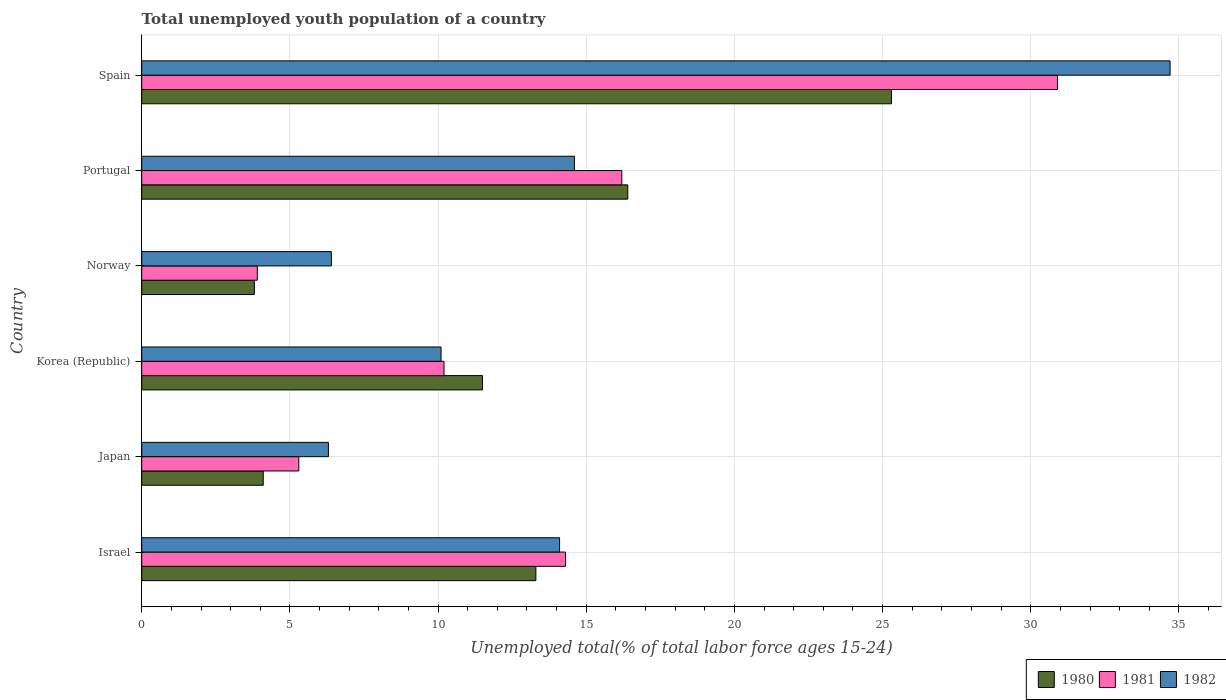How many groups of bars are there?
Your answer should be very brief. 6. Are the number of bars on each tick of the Y-axis equal?
Offer a terse response. Yes. How many bars are there on the 4th tick from the top?
Make the answer very short. 3. How many bars are there on the 4th tick from the bottom?
Provide a short and direct response. 3. What is the label of the 6th group of bars from the top?
Provide a succinct answer. Israel. What is the percentage of total unemployed youth population of a country in 1980 in Portugal?
Provide a succinct answer. 16.4. Across all countries, what is the maximum percentage of total unemployed youth population of a country in 1980?
Your answer should be very brief. 25.3. Across all countries, what is the minimum percentage of total unemployed youth population of a country in 1980?
Your answer should be very brief. 3.8. In which country was the percentage of total unemployed youth population of a country in 1981 maximum?
Provide a succinct answer. Spain. In which country was the percentage of total unemployed youth population of a country in 1982 minimum?
Give a very brief answer. Japan. What is the total percentage of total unemployed youth population of a country in 1980 in the graph?
Your answer should be very brief. 74.4. What is the difference between the percentage of total unemployed youth population of a country in 1982 in Israel and that in Japan?
Your answer should be compact. 7.8. What is the difference between the percentage of total unemployed youth population of a country in 1981 in Spain and the percentage of total unemployed youth population of a country in 1980 in Portugal?
Offer a very short reply. 14.5. What is the average percentage of total unemployed youth population of a country in 1980 per country?
Your response must be concise. 12.4. In how many countries, is the percentage of total unemployed youth population of a country in 1980 greater than 6 %?
Give a very brief answer. 4. What is the ratio of the percentage of total unemployed youth population of a country in 1982 in Korea (Republic) to that in Portugal?
Ensure brevity in your answer.  0.69. What is the difference between the highest and the second highest percentage of total unemployed youth population of a country in 1981?
Offer a very short reply. 14.7. What is the difference between the highest and the lowest percentage of total unemployed youth population of a country in 1981?
Ensure brevity in your answer.  27. In how many countries, is the percentage of total unemployed youth population of a country in 1981 greater than the average percentage of total unemployed youth population of a country in 1981 taken over all countries?
Offer a very short reply. 3. What does the 1st bar from the top in Portugal represents?
Make the answer very short. 1982. What does the 1st bar from the bottom in Japan represents?
Keep it short and to the point. 1980. Is it the case that in every country, the sum of the percentage of total unemployed youth population of a country in 1981 and percentage of total unemployed youth population of a country in 1980 is greater than the percentage of total unemployed youth population of a country in 1982?
Your answer should be very brief. Yes. How many countries are there in the graph?
Offer a terse response. 6. What is the difference between two consecutive major ticks on the X-axis?
Offer a terse response. 5. Does the graph contain any zero values?
Offer a terse response. No. Does the graph contain grids?
Your answer should be compact. Yes. Where does the legend appear in the graph?
Offer a terse response. Bottom right. What is the title of the graph?
Offer a terse response. Total unemployed youth population of a country. Does "1984" appear as one of the legend labels in the graph?
Give a very brief answer. No. What is the label or title of the X-axis?
Your response must be concise. Unemployed total(% of total labor force ages 15-24). What is the label or title of the Y-axis?
Your answer should be very brief. Country. What is the Unemployed total(% of total labor force ages 15-24) of 1980 in Israel?
Provide a short and direct response. 13.3. What is the Unemployed total(% of total labor force ages 15-24) in 1981 in Israel?
Provide a short and direct response. 14.3. What is the Unemployed total(% of total labor force ages 15-24) in 1982 in Israel?
Ensure brevity in your answer.  14.1. What is the Unemployed total(% of total labor force ages 15-24) in 1980 in Japan?
Give a very brief answer. 4.1. What is the Unemployed total(% of total labor force ages 15-24) of 1981 in Japan?
Provide a succinct answer. 5.3. What is the Unemployed total(% of total labor force ages 15-24) in 1982 in Japan?
Offer a very short reply. 6.3. What is the Unemployed total(% of total labor force ages 15-24) of 1980 in Korea (Republic)?
Offer a terse response. 11.5. What is the Unemployed total(% of total labor force ages 15-24) of 1981 in Korea (Republic)?
Your answer should be compact. 10.2. What is the Unemployed total(% of total labor force ages 15-24) in 1982 in Korea (Republic)?
Your answer should be compact. 10.1. What is the Unemployed total(% of total labor force ages 15-24) of 1980 in Norway?
Your answer should be very brief. 3.8. What is the Unemployed total(% of total labor force ages 15-24) in 1981 in Norway?
Offer a very short reply. 3.9. What is the Unemployed total(% of total labor force ages 15-24) in 1982 in Norway?
Your answer should be very brief. 6.4. What is the Unemployed total(% of total labor force ages 15-24) of 1980 in Portugal?
Ensure brevity in your answer.  16.4. What is the Unemployed total(% of total labor force ages 15-24) of 1981 in Portugal?
Your answer should be compact. 16.2. What is the Unemployed total(% of total labor force ages 15-24) in 1982 in Portugal?
Ensure brevity in your answer.  14.6. What is the Unemployed total(% of total labor force ages 15-24) of 1980 in Spain?
Give a very brief answer. 25.3. What is the Unemployed total(% of total labor force ages 15-24) in 1981 in Spain?
Offer a terse response. 30.9. What is the Unemployed total(% of total labor force ages 15-24) of 1982 in Spain?
Offer a very short reply. 34.7. Across all countries, what is the maximum Unemployed total(% of total labor force ages 15-24) in 1980?
Keep it short and to the point. 25.3. Across all countries, what is the maximum Unemployed total(% of total labor force ages 15-24) of 1981?
Provide a short and direct response. 30.9. Across all countries, what is the maximum Unemployed total(% of total labor force ages 15-24) of 1982?
Your answer should be compact. 34.7. Across all countries, what is the minimum Unemployed total(% of total labor force ages 15-24) of 1980?
Provide a succinct answer. 3.8. Across all countries, what is the minimum Unemployed total(% of total labor force ages 15-24) of 1981?
Give a very brief answer. 3.9. Across all countries, what is the minimum Unemployed total(% of total labor force ages 15-24) in 1982?
Ensure brevity in your answer.  6.3. What is the total Unemployed total(% of total labor force ages 15-24) of 1980 in the graph?
Your answer should be compact. 74.4. What is the total Unemployed total(% of total labor force ages 15-24) of 1981 in the graph?
Make the answer very short. 80.8. What is the total Unemployed total(% of total labor force ages 15-24) in 1982 in the graph?
Your answer should be very brief. 86.2. What is the difference between the Unemployed total(% of total labor force ages 15-24) of 1982 in Israel and that in Japan?
Ensure brevity in your answer.  7.8. What is the difference between the Unemployed total(% of total labor force ages 15-24) in 1980 in Israel and that in Korea (Republic)?
Your response must be concise. 1.8. What is the difference between the Unemployed total(% of total labor force ages 15-24) in 1982 in Israel and that in Korea (Republic)?
Offer a terse response. 4. What is the difference between the Unemployed total(% of total labor force ages 15-24) in 1982 in Israel and that in Norway?
Provide a short and direct response. 7.7. What is the difference between the Unemployed total(% of total labor force ages 15-24) of 1981 in Israel and that in Portugal?
Keep it short and to the point. -1.9. What is the difference between the Unemployed total(% of total labor force ages 15-24) of 1982 in Israel and that in Portugal?
Provide a succinct answer. -0.5. What is the difference between the Unemployed total(% of total labor force ages 15-24) in 1981 in Israel and that in Spain?
Provide a short and direct response. -16.6. What is the difference between the Unemployed total(% of total labor force ages 15-24) of 1982 in Israel and that in Spain?
Provide a short and direct response. -20.6. What is the difference between the Unemployed total(% of total labor force ages 15-24) of 1982 in Japan and that in Korea (Republic)?
Give a very brief answer. -3.8. What is the difference between the Unemployed total(% of total labor force ages 15-24) of 1981 in Japan and that in Portugal?
Ensure brevity in your answer.  -10.9. What is the difference between the Unemployed total(% of total labor force ages 15-24) in 1982 in Japan and that in Portugal?
Your answer should be compact. -8.3. What is the difference between the Unemployed total(% of total labor force ages 15-24) of 1980 in Japan and that in Spain?
Your answer should be very brief. -21.2. What is the difference between the Unemployed total(% of total labor force ages 15-24) of 1981 in Japan and that in Spain?
Make the answer very short. -25.6. What is the difference between the Unemployed total(% of total labor force ages 15-24) of 1982 in Japan and that in Spain?
Ensure brevity in your answer.  -28.4. What is the difference between the Unemployed total(% of total labor force ages 15-24) in 1980 in Korea (Republic) and that in Norway?
Your answer should be compact. 7.7. What is the difference between the Unemployed total(% of total labor force ages 15-24) in 1981 in Korea (Republic) and that in Norway?
Make the answer very short. 6.3. What is the difference between the Unemployed total(% of total labor force ages 15-24) in 1982 in Korea (Republic) and that in Norway?
Provide a short and direct response. 3.7. What is the difference between the Unemployed total(% of total labor force ages 15-24) in 1982 in Korea (Republic) and that in Portugal?
Offer a very short reply. -4.5. What is the difference between the Unemployed total(% of total labor force ages 15-24) of 1980 in Korea (Republic) and that in Spain?
Give a very brief answer. -13.8. What is the difference between the Unemployed total(% of total labor force ages 15-24) of 1981 in Korea (Republic) and that in Spain?
Make the answer very short. -20.7. What is the difference between the Unemployed total(% of total labor force ages 15-24) in 1982 in Korea (Republic) and that in Spain?
Your answer should be compact. -24.6. What is the difference between the Unemployed total(% of total labor force ages 15-24) of 1980 in Norway and that in Portugal?
Give a very brief answer. -12.6. What is the difference between the Unemployed total(% of total labor force ages 15-24) of 1981 in Norway and that in Portugal?
Ensure brevity in your answer.  -12.3. What is the difference between the Unemployed total(% of total labor force ages 15-24) of 1982 in Norway and that in Portugal?
Ensure brevity in your answer.  -8.2. What is the difference between the Unemployed total(% of total labor force ages 15-24) of 1980 in Norway and that in Spain?
Offer a terse response. -21.5. What is the difference between the Unemployed total(% of total labor force ages 15-24) of 1982 in Norway and that in Spain?
Provide a short and direct response. -28.3. What is the difference between the Unemployed total(% of total labor force ages 15-24) in 1981 in Portugal and that in Spain?
Give a very brief answer. -14.7. What is the difference between the Unemployed total(% of total labor force ages 15-24) of 1982 in Portugal and that in Spain?
Provide a succinct answer. -20.1. What is the difference between the Unemployed total(% of total labor force ages 15-24) in 1981 in Israel and the Unemployed total(% of total labor force ages 15-24) in 1982 in Japan?
Provide a short and direct response. 8. What is the difference between the Unemployed total(% of total labor force ages 15-24) of 1980 in Israel and the Unemployed total(% of total labor force ages 15-24) of 1981 in Korea (Republic)?
Keep it short and to the point. 3.1. What is the difference between the Unemployed total(% of total labor force ages 15-24) of 1980 in Israel and the Unemployed total(% of total labor force ages 15-24) of 1982 in Korea (Republic)?
Offer a very short reply. 3.2. What is the difference between the Unemployed total(% of total labor force ages 15-24) of 1981 in Israel and the Unemployed total(% of total labor force ages 15-24) of 1982 in Korea (Republic)?
Offer a terse response. 4.2. What is the difference between the Unemployed total(% of total labor force ages 15-24) of 1980 in Israel and the Unemployed total(% of total labor force ages 15-24) of 1981 in Norway?
Offer a terse response. 9.4. What is the difference between the Unemployed total(% of total labor force ages 15-24) of 1980 in Israel and the Unemployed total(% of total labor force ages 15-24) of 1981 in Spain?
Provide a succinct answer. -17.6. What is the difference between the Unemployed total(% of total labor force ages 15-24) in 1980 in Israel and the Unemployed total(% of total labor force ages 15-24) in 1982 in Spain?
Your response must be concise. -21.4. What is the difference between the Unemployed total(% of total labor force ages 15-24) of 1981 in Israel and the Unemployed total(% of total labor force ages 15-24) of 1982 in Spain?
Make the answer very short. -20.4. What is the difference between the Unemployed total(% of total labor force ages 15-24) in 1980 in Japan and the Unemployed total(% of total labor force ages 15-24) in 1982 in Korea (Republic)?
Your answer should be compact. -6. What is the difference between the Unemployed total(% of total labor force ages 15-24) in 1981 in Japan and the Unemployed total(% of total labor force ages 15-24) in 1982 in Korea (Republic)?
Provide a short and direct response. -4.8. What is the difference between the Unemployed total(% of total labor force ages 15-24) in 1980 in Japan and the Unemployed total(% of total labor force ages 15-24) in 1982 in Norway?
Ensure brevity in your answer.  -2.3. What is the difference between the Unemployed total(% of total labor force ages 15-24) in 1981 in Japan and the Unemployed total(% of total labor force ages 15-24) in 1982 in Norway?
Your answer should be very brief. -1.1. What is the difference between the Unemployed total(% of total labor force ages 15-24) in 1980 in Japan and the Unemployed total(% of total labor force ages 15-24) in 1981 in Portugal?
Your response must be concise. -12.1. What is the difference between the Unemployed total(% of total labor force ages 15-24) in 1980 in Japan and the Unemployed total(% of total labor force ages 15-24) in 1982 in Portugal?
Offer a very short reply. -10.5. What is the difference between the Unemployed total(% of total labor force ages 15-24) in 1980 in Japan and the Unemployed total(% of total labor force ages 15-24) in 1981 in Spain?
Offer a terse response. -26.8. What is the difference between the Unemployed total(% of total labor force ages 15-24) of 1980 in Japan and the Unemployed total(% of total labor force ages 15-24) of 1982 in Spain?
Your response must be concise. -30.6. What is the difference between the Unemployed total(% of total labor force ages 15-24) of 1981 in Japan and the Unemployed total(% of total labor force ages 15-24) of 1982 in Spain?
Offer a terse response. -29.4. What is the difference between the Unemployed total(% of total labor force ages 15-24) in 1980 in Korea (Republic) and the Unemployed total(% of total labor force ages 15-24) in 1981 in Norway?
Your answer should be very brief. 7.6. What is the difference between the Unemployed total(% of total labor force ages 15-24) of 1980 in Korea (Republic) and the Unemployed total(% of total labor force ages 15-24) of 1982 in Norway?
Ensure brevity in your answer.  5.1. What is the difference between the Unemployed total(% of total labor force ages 15-24) in 1981 in Korea (Republic) and the Unemployed total(% of total labor force ages 15-24) in 1982 in Norway?
Offer a terse response. 3.8. What is the difference between the Unemployed total(% of total labor force ages 15-24) of 1980 in Korea (Republic) and the Unemployed total(% of total labor force ages 15-24) of 1981 in Spain?
Offer a very short reply. -19.4. What is the difference between the Unemployed total(% of total labor force ages 15-24) of 1980 in Korea (Republic) and the Unemployed total(% of total labor force ages 15-24) of 1982 in Spain?
Offer a terse response. -23.2. What is the difference between the Unemployed total(% of total labor force ages 15-24) of 1981 in Korea (Republic) and the Unemployed total(% of total labor force ages 15-24) of 1982 in Spain?
Keep it short and to the point. -24.5. What is the difference between the Unemployed total(% of total labor force ages 15-24) of 1980 in Norway and the Unemployed total(% of total labor force ages 15-24) of 1981 in Portugal?
Offer a very short reply. -12.4. What is the difference between the Unemployed total(% of total labor force ages 15-24) of 1980 in Norway and the Unemployed total(% of total labor force ages 15-24) of 1982 in Portugal?
Offer a terse response. -10.8. What is the difference between the Unemployed total(% of total labor force ages 15-24) in 1981 in Norway and the Unemployed total(% of total labor force ages 15-24) in 1982 in Portugal?
Offer a terse response. -10.7. What is the difference between the Unemployed total(% of total labor force ages 15-24) of 1980 in Norway and the Unemployed total(% of total labor force ages 15-24) of 1981 in Spain?
Keep it short and to the point. -27.1. What is the difference between the Unemployed total(% of total labor force ages 15-24) in 1980 in Norway and the Unemployed total(% of total labor force ages 15-24) in 1982 in Spain?
Offer a terse response. -30.9. What is the difference between the Unemployed total(% of total labor force ages 15-24) in 1981 in Norway and the Unemployed total(% of total labor force ages 15-24) in 1982 in Spain?
Offer a very short reply. -30.8. What is the difference between the Unemployed total(% of total labor force ages 15-24) of 1980 in Portugal and the Unemployed total(% of total labor force ages 15-24) of 1982 in Spain?
Ensure brevity in your answer.  -18.3. What is the difference between the Unemployed total(% of total labor force ages 15-24) of 1981 in Portugal and the Unemployed total(% of total labor force ages 15-24) of 1982 in Spain?
Provide a short and direct response. -18.5. What is the average Unemployed total(% of total labor force ages 15-24) of 1980 per country?
Your answer should be very brief. 12.4. What is the average Unemployed total(% of total labor force ages 15-24) of 1981 per country?
Provide a succinct answer. 13.47. What is the average Unemployed total(% of total labor force ages 15-24) in 1982 per country?
Your response must be concise. 14.37. What is the difference between the Unemployed total(% of total labor force ages 15-24) in 1980 and Unemployed total(% of total labor force ages 15-24) in 1982 in Israel?
Offer a very short reply. -0.8. What is the difference between the Unemployed total(% of total labor force ages 15-24) of 1981 and Unemployed total(% of total labor force ages 15-24) of 1982 in Israel?
Your response must be concise. 0.2. What is the difference between the Unemployed total(% of total labor force ages 15-24) in 1980 and Unemployed total(% of total labor force ages 15-24) in 1981 in Japan?
Keep it short and to the point. -1.2. What is the difference between the Unemployed total(% of total labor force ages 15-24) in 1981 and Unemployed total(% of total labor force ages 15-24) in 1982 in Japan?
Offer a terse response. -1. What is the difference between the Unemployed total(% of total labor force ages 15-24) in 1980 and Unemployed total(% of total labor force ages 15-24) in 1981 in Norway?
Your response must be concise. -0.1. What is the difference between the Unemployed total(% of total labor force ages 15-24) of 1980 and Unemployed total(% of total labor force ages 15-24) of 1982 in Norway?
Ensure brevity in your answer.  -2.6. What is the difference between the Unemployed total(% of total labor force ages 15-24) of 1981 and Unemployed total(% of total labor force ages 15-24) of 1982 in Portugal?
Make the answer very short. 1.6. What is the difference between the Unemployed total(% of total labor force ages 15-24) of 1980 and Unemployed total(% of total labor force ages 15-24) of 1981 in Spain?
Keep it short and to the point. -5.6. What is the difference between the Unemployed total(% of total labor force ages 15-24) in 1980 and Unemployed total(% of total labor force ages 15-24) in 1982 in Spain?
Your answer should be compact. -9.4. What is the ratio of the Unemployed total(% of total labor force ages 15-24) in 1980 in Israel to that in Japan?
Keep it short and to the point. 3.24. What is the ratio of the Unemployed total(% of total labor force ages 15-24) of 1981 in Israel to that in Japan?
Ensure brevity in your answer.  2.7. What is the ratio of the Unemployed total(% of total labor force ages 15-24) in 1982 in Israel to that in Japan?
Make the answer very short. 2.24. What is the ratio of the Unemployed total(% of total labor force ages 15-24) of 1980 in Israel to that in Korea (Republic)?
Give a very brief answer. 1.16. What is the ratio of the Unemployed total(% of total labor force ages 15-24) of 1981 in Israel to that in Korea (Republic)?
Give a very brief answer. 1.4. What is the ratio of the Unemployed total(% of total labor force ages 15-24) in 1982 in Israel to that in Korea (Republic)?
Ensure brevity in your answer.  1.4. What is the ratio of the Unemployed total(% of total labor force ages 15-24) in 1981 in Israel to that in Norway?
Make the answer very short. 3.67. What is the ratio of the Unemployed total(% of total labor force ages 15-24) in 1982 in Israel to that in Norway?
Your answer should be very brief. 2.2. What is the ratio of the Unemployed total(% of total labor force ages 15-24) of 1980 in Israel to that in Portugal?
Keep it short and to the point. 0.81. What is the ratio of the Unemployed total(% of total labor force ages 15-24) in 1981 in Israel to that in Portugal?
Your response must be concise. 0.88. What is the ratio of the Unemployed total(% of total labor force ages 15-24) of 1982 in Israel to that in Portugal?
Make the answer very short. 0.97. What is the ratio of the Unemployed total(% of total labor force ages 15-24) in 1980 in Israel to that in Spain?
Offer a very short reply. 0.53. What is the ratio of the Unemployed total(% of total labor force ages 15-24) in 1981 in Israel to that in Spain?
Your answer should be compact. 0.46. What is the ratio of the Unemployed total(% of total labor force ages 15-24) in 1982 in Israel to that in Spain?
Your response must be concise. 0.41. What is the ratio of the Unemployed total(% of total labor force ages 15-24) in 1980 in Japan to that in Korea (Republic)?
Keep it short and to the point. 0.36. What is the ratio of the Unemployed total(% of total labor force ages 15-24) in 1981 in Japan to that in Korea (Republic)?
Ensure brevity in your answer.  0.52. What is the ratio of the Unemployed total(% of total labor force ages 15-24) in 1982 in Japan to that in Korea (Republic)?
Your answer should be very brief. 0.62. What is the ratio of the Unemployed total(% of total labor force ages 15-24) of 1980 in Japan to that in Norway?
Offer a terse response. 1.08. What is the ratio of the Unemployed total(% of total labor force ages 15-24) of 1981 in Japan to that in Norway?
Offer a very short reply. 1.36. What is the ratio of the Unemployed total(% of total labor force ages 15-24) in 1982 in Japan to that in Norway?
Your answer should be very brief. 0.98. What is the ratio of the Unemployed total(% of total labor force ages 15-24) of 1981 in Japan to that in Portugal?
Offer a terse response. 0.33. What is the ratio of the Unemployed total(% of total labor force ages 15-24) of 1982 in Japan to that in Portugal?
Make the answer very short. 0.43. What is the ratio of the Unemployed total(% of total labor force ages 15-24) in 1980 in Japan to that in Spain?
Provide a short and direct response. 0.16. What is the ratio of the Unemployed total(% of total labor force ages 15-24) in 1981 in Japan to that in Spain?
Offer a terse response. 0.17. What is the ratio of the Unemployed total(% of total labor force ages 15-24) of 1982 in Japan to that in Spain?
Give a very brief answer. 0.18. What is the ratio of the Unemployed total(% of total labor force ages 15-24) in 1980 in Korea (Republic) to that in Norway?
Offer a very short reply. 3.03. What is the ratio of the Unemployed total(% of total labor force ages 15-24) in 1981 in Korea (Republic) to that in Norway?
Your answer should be compact. 2.62. What is the ratio of the Unemployed total(% of total labor force ages 15-24) of 1982 in Korea (Republic) to that in Norway?
Your answer should be compact. 1.58. What is the ratio of the Unemployed total(% of total labor force ages 15-24) in 1980 in Korea (Republic) to that in Portugal?
Give a very brief answer. 0.7. What is the ratio of the Unemployed total(% of total labor force ages 15-24) of 1981 in Korea (Republic) to that in Portugal?
Make the answer very short. 0.63. What is the ratio of the Unemployed total(% of total labor force ages 15-24) of 1982 in Korea (Republic) to that in Portugal?
Provide a succinct answer. 0.69. What is the ratio of the Unemployed total(% of total labor force ages 15-24) of 1980 in Korea (Republic) to that in Spain?
Give a very brief answer. 0.45. What is the ratio of the Unemployed total(% of total labor force ages 15-24) of 1981 in Korea (Republic) to that in Spain?
Provide a succinct answer. 0.33. What is the ratio of the Unemployed total(% of total labor force ages 15-24) in 1982 in Korea (Republic) to that in Spain?
Give a very brief answer. 0.29. What is the ratio of the Unemployed total(% of total labor force ages 15-24) in 1980 in Norway to that in Portugal?
Your answer should be very brief. 0.23. What is the ratio of the Unemployed total(% of total labor force ages 15-24) of 1981 in Norway to that in Portugal?
Your answer should be compact. 0.24. What is the ratio of the Unemployed total(% of total labor force ages 15-24) in 1982 in Norway to that in Portugal?
Give a very brief answer. 0.44. What is the ratio of the Unemployed total(% of total labor force ages 15-24) of 1980 in Norway to that in Spain?
Ensure brevity in your answer.  0.15. What is the ratio of the Unemployed total(% of total labor force ages 15-24) of 1981 in Norway to that in Spain?
Your answer should be very brief. 0.13. What is the ratio of the Unemployed total(% of total labor force ages 15-24) in 1982 in Norway to that in Spain?
Offer a terse response. 0.18. What is the ratio of the Unemployed total(% of total labor force ages 15-24) in 1980 in Portugal to that in Spain?
Your answer should be compact. 0.65. What is the ratio of the Unemployed total(% of total labor force ages 15-24) of 1981 in Portugal to that in Spain?
Offer a very short reply. 0.52. What is the ratio of the Unemployed total(% of total labor force ages 15-24) of 1982 in Portugal to that in Spain?
Your answer should be very brief. 0.42. What is the difference between the highest and the second highest Unemployed total(% of total labor force ages 15-24) in 1982?
Offer a terse response. 20.1. What is the difference between the highest and the lowest Unemployed total(% of total labor force ages 15-24) in 1980?
Make the answer very short. 21.5. What is the difference between the highest and the lowest Unemployed total(% of total labor force ages 15-24) of 1982?
Offer a very short reply. 28.4. 